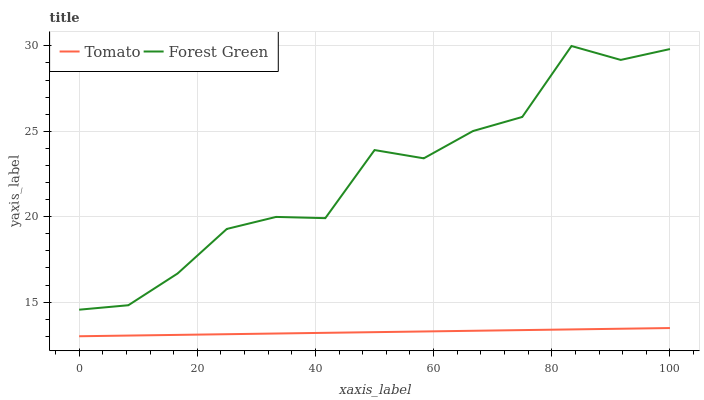Does Tomato have the minimum area under the curve?
Answer yes or no. Yes. Does Forest Green have the maximum area under the curve?
Answer yes or no. Yes. Does Forest Green have the minimum area under the curve?
Answer yes or no. No. Is Tomato the smoothest?
Answer yes or no. Yes. Is Forest Green the roughest?
Answer yes or no. Yes. Is Forest Green the smoothest?
Answer yes or no. No. Does Forest Green have the lowest value?
Answer yes or no. No. Does Forest Green have the highest value?
Answer yes or no. Yes. Is Tomato less than Forest Green?
Answer yes or no. Yes. Is Forest Green greater than Tomato?
Answer yes or no. Yes. Does Tomato intersect Forest Green?
Answer yes or no. No. 